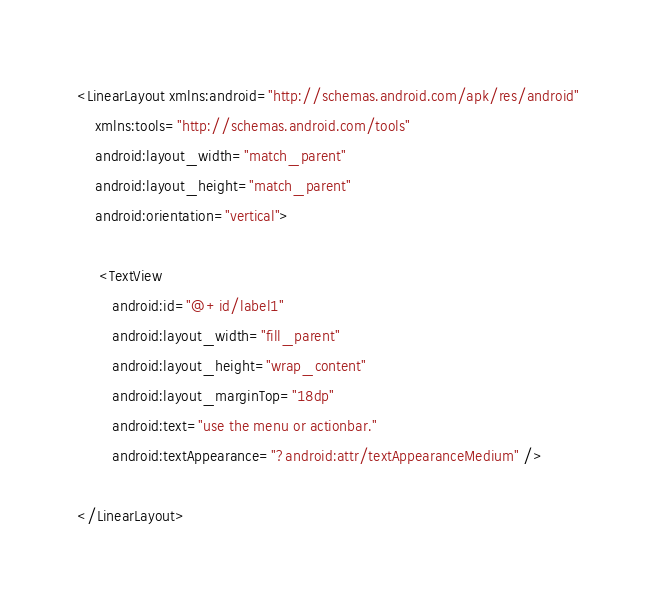Convert code to text. <code><loc_0><loc_0><loc_500><loc_500><_XML_><LinearLayout xmlns:android="http://schemas.android.com/apk/res/android"
    xmlns:tools="http://schemas.android.com/tools"
    android:layout_width="match_parent"
    android:layout_height="match_parent"
    android:orientation="vertical">

     <TextView
        android:id="@+id/label1"
        android:layout_width="fill_parent"
        android:layout_height="wrap_content"
        android:layout_marginTop="18dp"
        android:text="use the menu or actionbar."
        android:textAppearance="?android:attr/textAppearanceMedium" />

</LinearLayout></code> 